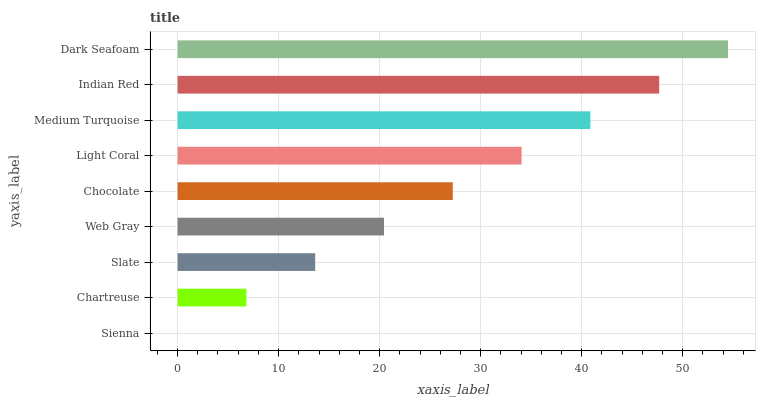Is Sienna the minimum?
Answer yes or no. Yes. Is Dark Seafoam the maximum?
Answer yes or no. Yes. Is Chartreuse the minimum?
Answer yes or no. No. Is Chartreuse the maximum?
Answer yes or no. No. Is Chartreuse greater than Sienna?
Answer yes or no. Yes. Is Sienna less than Chartreuse?
Answer yes or no. Yes. Is Sienna greater than Chartreuse?
Answer yes or no. No. Is Chartreuse less than Sienna?
Answer yes or no. No. Is Chocolate the high median?
Answer yes or no. Yes. Is Chocolate the low median?
Answer yes or no. Yes. Is Indian Red the high median?
Answer yes or no. No. Is Dark Seafoam the low median?
Answer yes or no. No. 